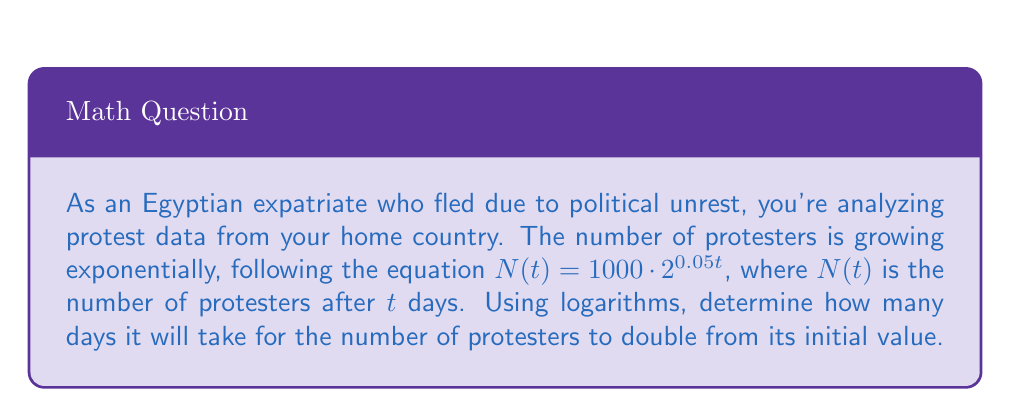Could you help me with this problem? Let's approach this step-by-step:

1) We want to find $t$ when $N(t)$ is twice the initial value. The initial value is when $t=0$:

   $N(0) = 1000 \cdot 2^{0.05 \cdot 0} = 1000$

2) So, we need to solve the equation:

   $2000 = 1000 \cdot 2^{0.05t}$

3) Divide both sides by 1000:

   $2 = 2^{0.05t}$

4) Now, let's apply the logarithm (base 2) to both sides:

   $\log_2(2) = \log_2(2^{0.05t})$

5) The left side simplifies to 1, and we can use the logarithm power rule on the right:

   $1 = 0.05t \cdot \log_2(2)$

6) $\log_2(2) = 1$, so our equation becomes:

   $1 = 0.05t$

7) Solve for $t$:

   $t = \frac{1}{0.05} = 20$

Therefore, it will take 20 days for the number of protesters to double.
Answer: 20 days 